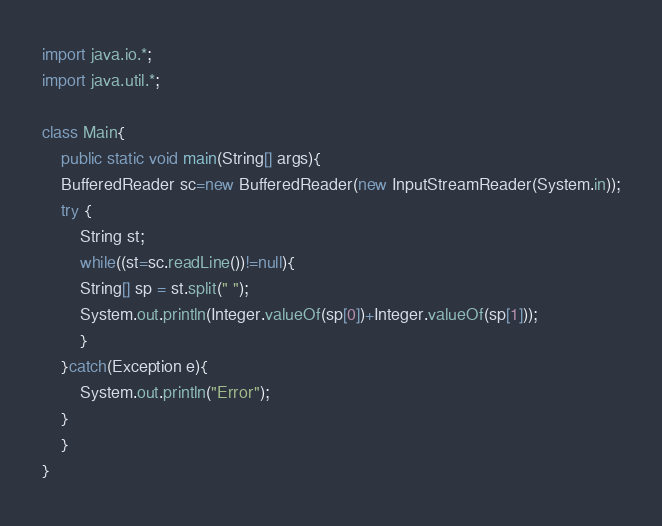Convert code to text. <code><loc_0><loc_0><loc_500><loc_500><_Java_>import java.io.*;
import java.util.*;

class Main{
    public static void main(String[] args){
	BufferedReader sc=new BufferedReader(new InputStreamReader(System.in));
	try {
	    String st;
	    while((st=sc.readLine())!=null){
		String[] sp = st.split(" ");
		System.out.println(Integer.valueOf(sp[0])+Integer.valueOf(sp[1]));
	    }
	}catch(Exception e){
	    System.out.println("Error");
	}
    }
}</code> 